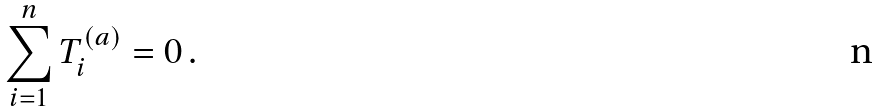<formula> <loc_0><loc_0><loc_500><loc_500>\sum _ { i = 1 } ^ { n } T _ { i } ^ { ( a ) } = 0 \, .</formula> 